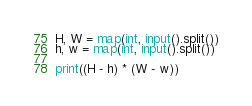Convert code to text. <code><loc_0><loc_0><loc_500><loc_500><_Python_>H, W = map(int, input().split())
h, w = map(int, input().split())

print((H - h) * (W - w))
</code> 